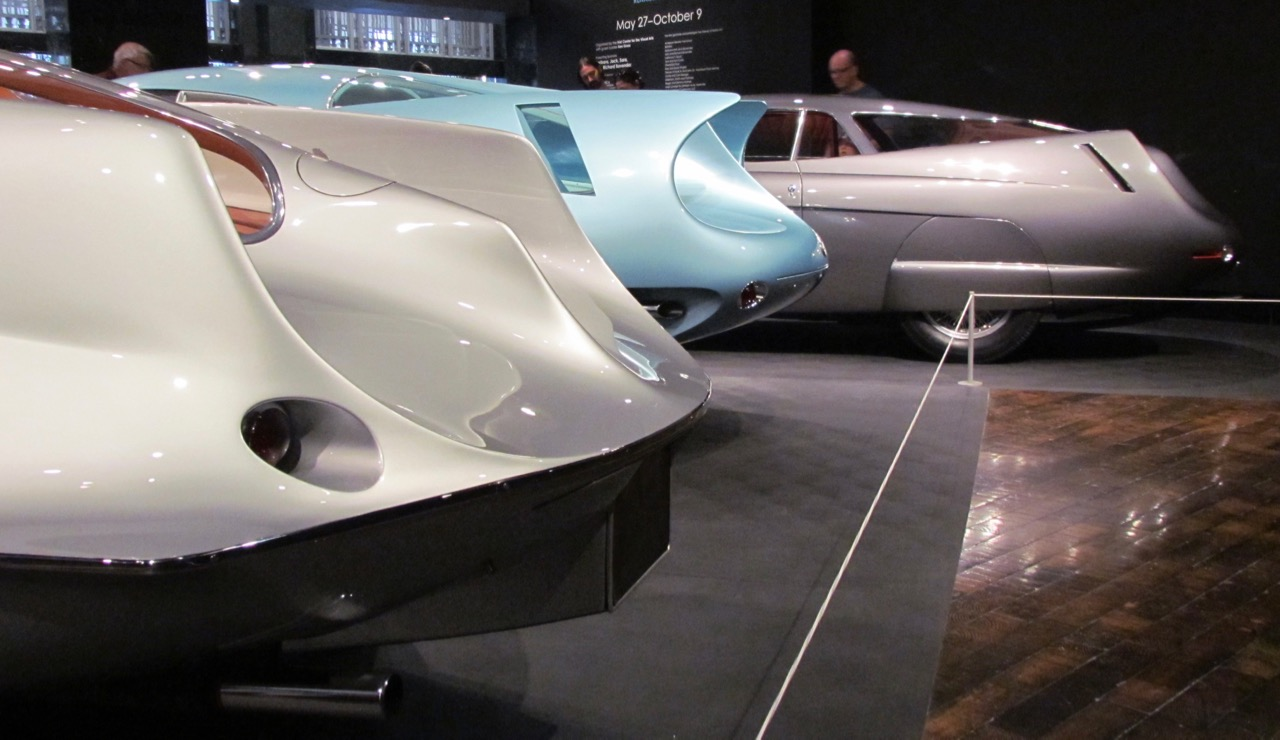What role do you think the circular side vents play in the overall design of these vehicles, beyond aesthetics? Beyond their aesthetic appeal, the circular side vents in these vehicles serve functional purposes linked to aerodynamic efficiency and engine cooling. By managing airflow, these vents help reduce turbulence around the car's body, contributing to smoother, faster movement. Additionally, they facilitate better cooling by directing air to crucial mechanical components, preventing overheating and ensuring optimal performance. The seamless integration of form and function in these design elements highlights the innovative spirit of the era, where beauty and engineering excellence were harmonized. I can definitely see how form and function blend seamlessly in these designs. Do you think these principles still influence modern car designs? Absolutely, the principles of aerodynamic efficiency established in the mid-20th century continue to influence modern car designs. Today, we see sleek, streamlined bodies, optimized for fuel efficiency and performance, much like the cars in the image. Advanced technologies such as wind tunnel testing and computational fluid dynamics (CFD) are used to perfect these designs. Moreover, modern vehicles often incorporate active aerodynamic features such as adjustable spoilers and air intakes, which adapt to driving conditions. The legacy of integrating aesthetic appeal with engineering prowess endures, driven by the perpetual quest for efficiency, performance, and cutting-edge style. Let's get imaginative. If these cars could transform into something entirely different, retaining their streamlined design, what would they become? Imagine these cars transforming into high-speed aquatic vessels, seamlessly transitioning from roads to water. Their streamlined bodies would split apart, unveiling hydrofoil wings that lift them above the water surface, reducing drag and allowing for extraordinary speeds. The circular side vents could transform into dynamic intakes, channeling water to maintain buoyancy and balance. These vehicles, with their smooth, flowing curves, would glide effortlessly over water, embodying a futuristic vision of versatile, amphibious transportation that melds the elegance of automotive design with the cutting-edge technology of marine engineering. 